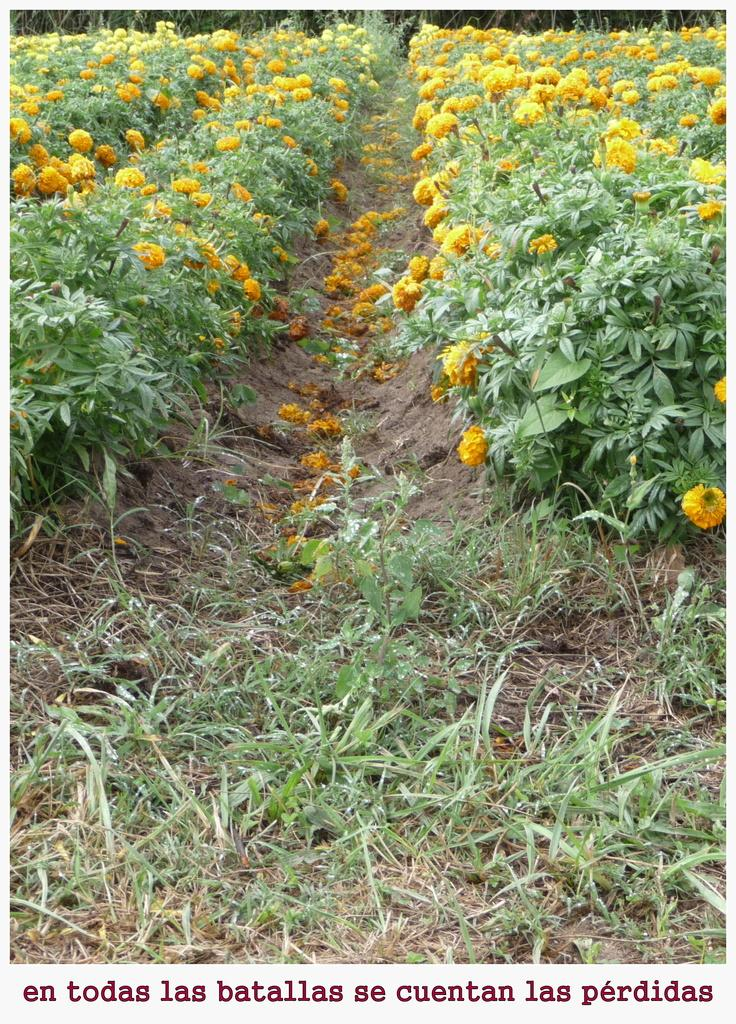What type of plants can be seen in the image? There are plants with flowers in the image. What is the ground covered with in the image? There is grass in the image. What type of stocking is hanging on the tree in the image? There is no stocking hanging on a tree in the image; it only features plants with flowers and grass. 